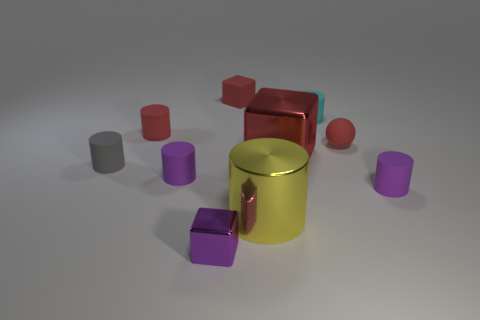Subtract all purple cylinders. How many cylinders are left? 4 Subtract all purple cylinders. How many cylinders are left? 4 Subtract all red cylinders. Subtract all purple balls. How many cylinders are left? 5 Subtract all cylinders. How many objects are left? 4 Subtract all tiny blue shiny blocks. Subtract all big metallic cylinders. How many objects are left? 9 Add 7 big yellow shiny cylinders. How many big yellow shiny cylinders are left? 8 Add 7 small blue cylinders. How many small blue cylinders exist? 7 Subtract 0 blue cylinders. How many objects are left? 10 